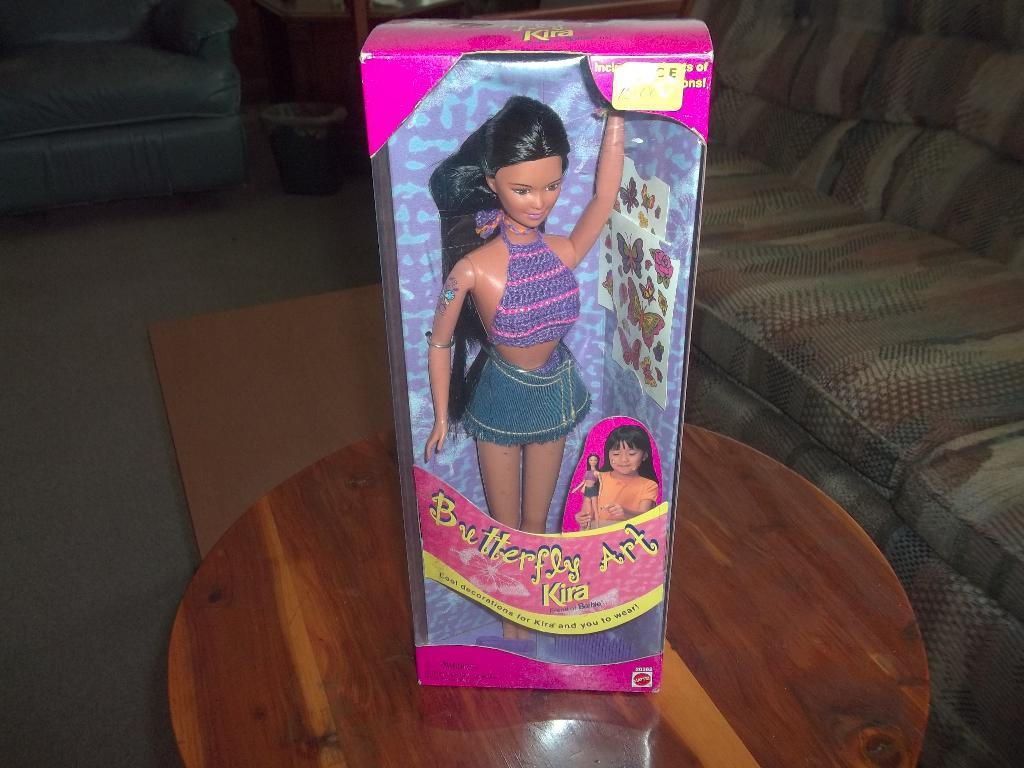What is the main subject of the image? The main subject of the image is a barbie doll. How is the barbie doll packaged? The barbie doll is packed in a box. Where is the box with the barbie doll located? The box is placed on a wooden table. What other object can be seen in the image? There is an object that resembles a dustbin in the image. Where is the dustbin located? The dustbin is placed on the floor. What type of frame is the barbie doll sitting in during the meeting with her brothers? There is no frame or meeting with brothers depicted in the image; it shows a barbie doll packed in a box on a wooden table. 